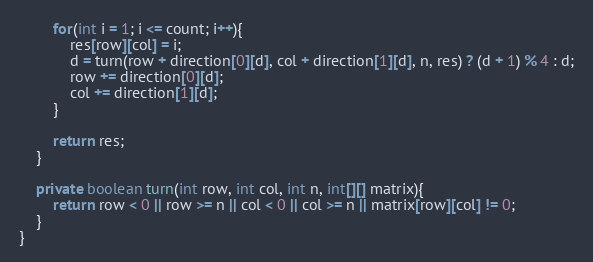<code> <loc_0><loc_0><loc_500><loc_500><_Java_>        for(int i = 1; i <= count; i++){
            res[row][col] = i;
            d = turn(row + direction[0][d], col + direction[1][d], n, res) ? (d + 1) % 4 : d;
            row += direction[0][d];
            col += direction[1][d];
        }
        
        return res;
    }
    
    private boolean turn(int row, int col, int n, int[][] matrix){
        return row < 0 || row >= n || col < 0 || col >= n || matrix[row][col] != 0;
    }
}
</code> 